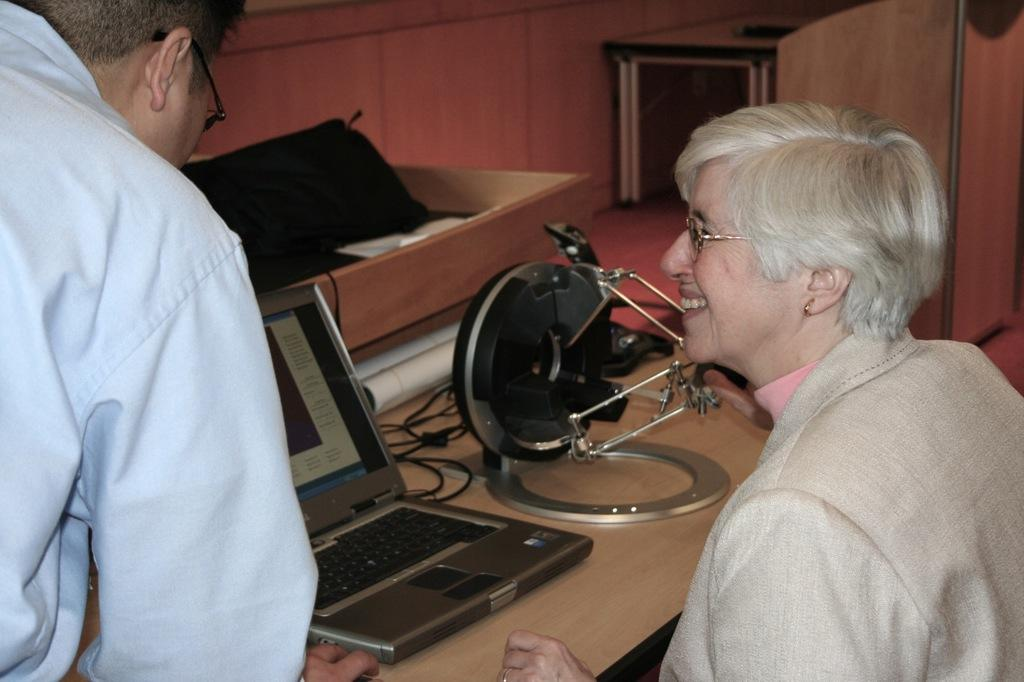What is the woman doing in the image? The woman is sitting in front of a table. What can be seen on the table in the image? There is a laptop on the table, along with other objects. What is the man doing in the image? The man is standing beside the woman and operating the laptop. How many people are present in the image? There are two people in the image, the woman and the man. What type of knowledge can be gained from the crook in the image? There is no crook present in the image, so no knowledge can be gained from it. 